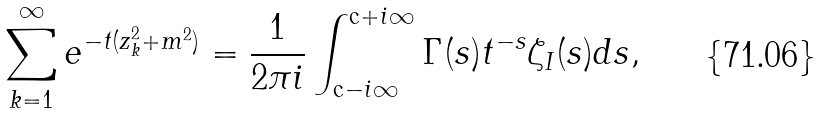<formula> <loc_0><loc_0><loc_500><loc_500>\sum _ { k = 1 } ^ { \infty } e ^ { - t ( z _ { k } ^ { 2 } + m ^ { 2 } ) } = \frac { 1 } { 2 \pi i } \int _ { \text {c} - i \infty } ^ { \text {c} + i \infty } \Gamma ( s ) t ^ { - s } \zeta _ { I } ( s ) d s ,</formula> 